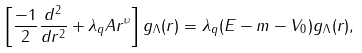<formula> <loc_0><loc_0><loc_500><loc_500>\left [ \frac { - 1 } 2 \frac { d ^ { 2 } } { d r ^ { 2 } } + \lambda _ { q } A r ^ { \upsilon } \right ] g _ { \Lambda } ( r ) = \lambda _ { q } ( E - m - V _ { 0 } ) g _ { \Lambda } ( r ) ,</formula> 